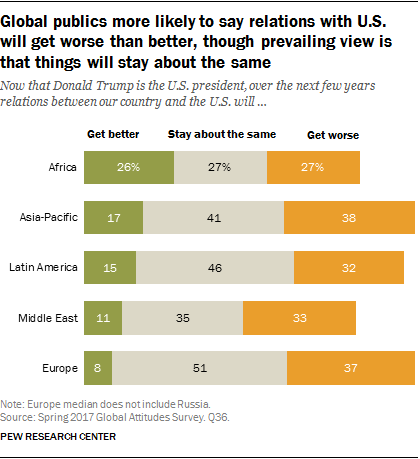Identify some key points in this picture. The ratio of green bars to median and smallest gray bar is 0.214583333... The color of the middle bars is gray. 